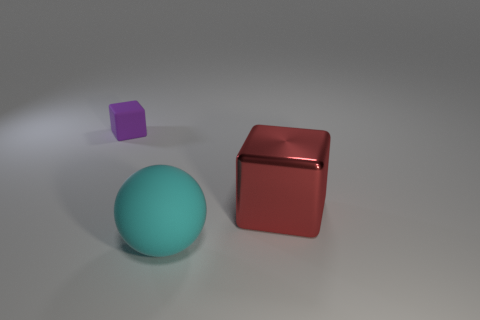What could be the relationship between the three objects in terms of their purpose? The objects could be part of a comparative display, possibly used to illustrate differences in color, size, and texture in an educational setting, or they could be decorative objects in a minimalistic interior design theme, emphasizing simplicity and form. 